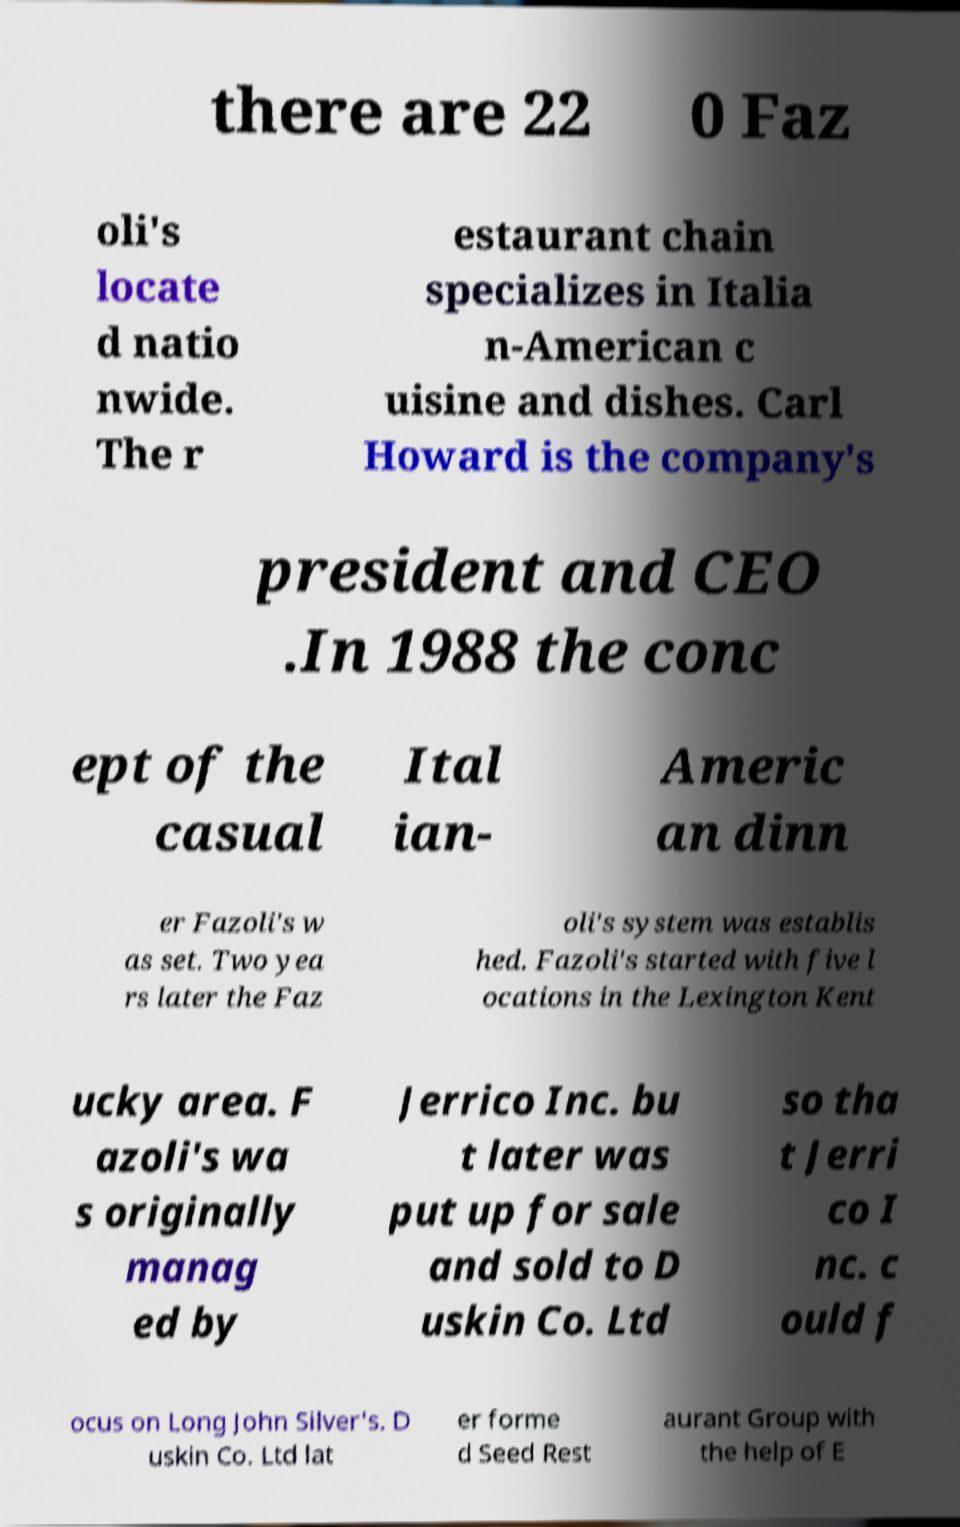For documentation purposes, I need the text within this image transcribed. Could you provide that? there are 22 0 Faz oli's locate d natio nwide. The r estaurant chain specializes in Italia n-American c uisine and dishes. Carl Howard is the company's president and CEO .In 1988 the conc ept of the casual Ital ian- Americ an dinn er Fazoli's w as set. Two yea rs later the Faz oli's system was establis hed. Fazoli's started with five l ocations in the Lexington Kent ucky area. F azoli's wa s originally manag ed by Jerrico Inc. bu t later was put up for sale and sold to D uskin Co. Ltd so tha t Jerri co I nc. c ould f ocus on Long John Silver's. D uskin Co. Ltd lat er forme d Seed Rest aurant Group with the help of E 